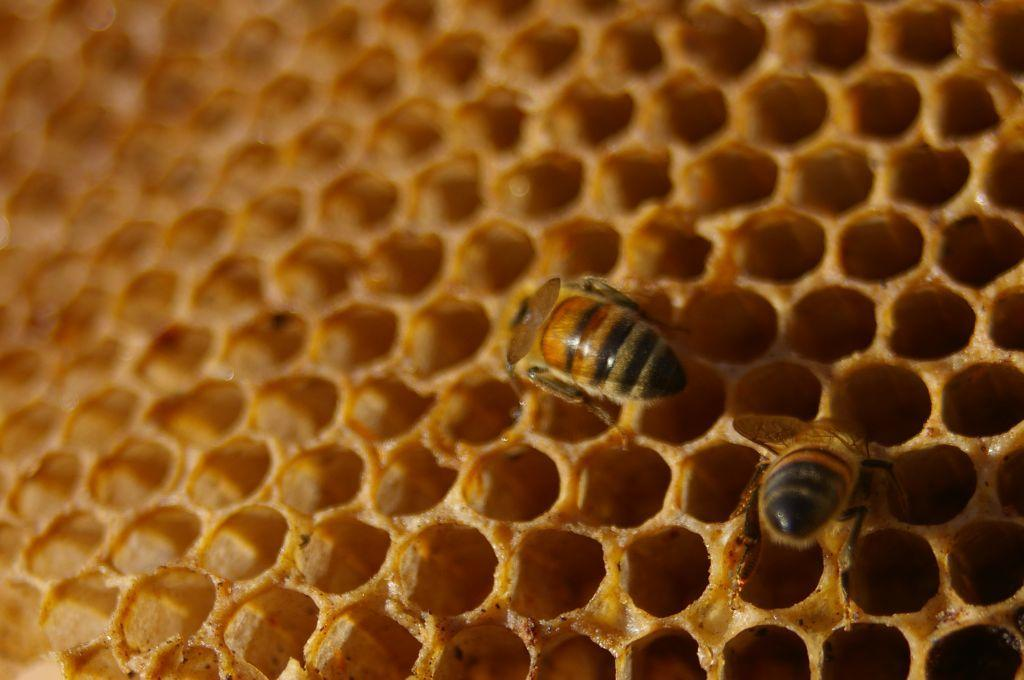What is the main subject of the image? The main subject of the image is a honey bee hive. Can you describe the contents of the hive? There are two honey bees in the hive. How does the honey bee hive stretch in the image? The honey bee hive does not stretch in the image; it is a stationary structure. 